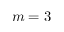<formula> <loc_0><loc_0><loc_500><loc_500>m = 3</formula> 